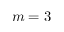<formula> <loc_0><loc_0><loc_500><loc_500>m = 3</formula> 